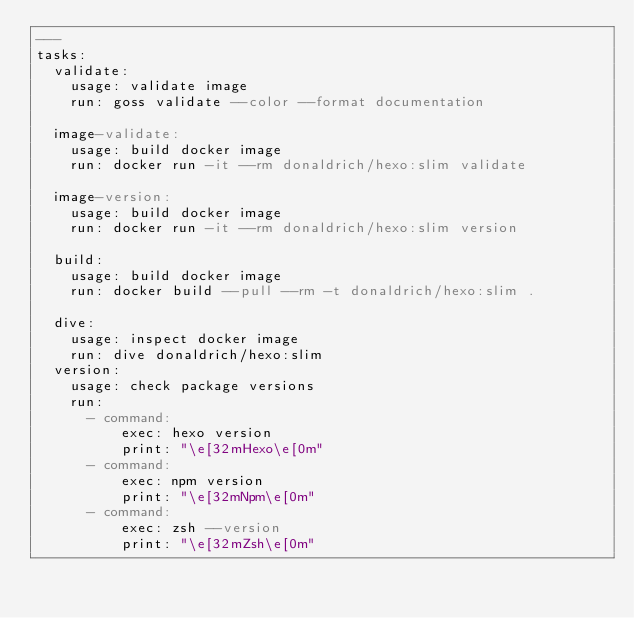Convert code to text. <code><loc_0><loc_0><loc_500><loc_500><_YAML_>---
tasks:
  validate:
    usage: validate image
    run: goss validate --color --format documentation

  image-validate:
    usage: build docker image
    run: docker run -it --rm donaldrich/hexo:slim validate

  image-version:
    usage: build docker image
    run: docker run -it --rm donaldrich/hexo:slim version

  build:
    usage: build docker image
    run: docker build --pull --rm -t donaldrich/hexo:slim .

  dive:
    usage: inspect docker image
    run: dive donaldrich/hexo:slim
  version:
    usage: check package versions
    run:
      - command:
          exec: hexo version
          print: "\e[32mHexo\e[0m"
      - command:
          exec: npm version
          print: "\e[32mNpm\e[0m"
      - command:
          exec: zsh --version
          print: "\e[32mZsh\e[0m"
</code> 